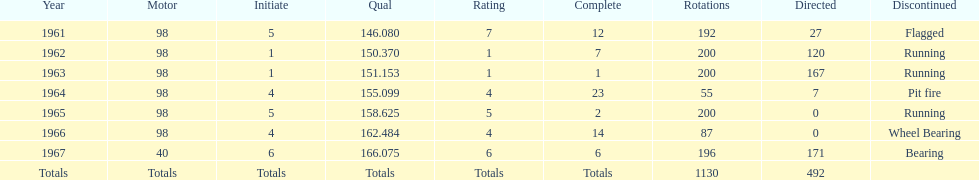In how many indy 500 races, has jones been flagged? 1. 